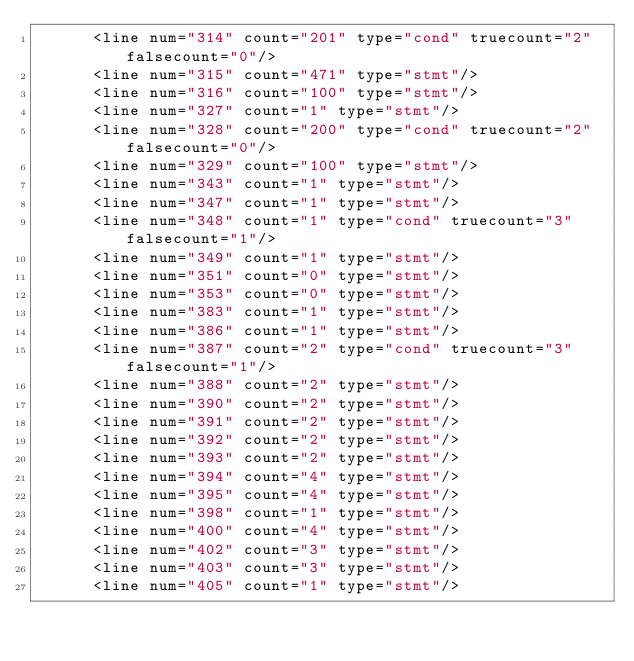<code> <loc_0><loc_0><loc_500><loc_500><_XML_>      <line num="314" count="201" type="cond" truecount="2" falsecount="0"/>
      <line num="315" count="471" type="stmt"/>
      <line num="316" count="100" type="stmt"/>
      <line num="327" count="1" type="stmt"/>
      <line num="328" count="200" type="cond" truecount="2" falsecount="0"/>
      <line num="329" count="100" type="stmt"/>
      <line num="343" count="1" type="stmt"/>
      <line num="347" count="1" type="stmt"/>
      <line num="348" count="1" type="cond" truecount="3" falsecount="1"/>
      <line num="349" count="1" type="stmt"/>
      <line num="351" count="0" type="stmt"/>
      <line num="353" count="0" type="stmt"/>
      <line num="383" count="1" type="stmt"/>
      <line num="386" count="1" type="stmt"/>
      <line num="387" count="2" type="cond" truecount="3" falsecount="1"/>
      <line num="388" count="2" type="stmt"/>
      <line num="390" count="2" type="stmt"/>
      <line num="391" count="2" type="stmt"/>
      <line num="392" count="2" type="stmt"/>
      <line num="393" count="2" type="stmt"/>
      <line num="394" count="4" type="stmt"/>
      <line num="395" count="4" type="stmt"/>
      <line num="398" count="1" type="stmt"/>
      <line num="400" count="4" type="stmt"/>
      <line num="402" count="3" type="stmt"/>
      <line num="403" count="3" type="stmt"/>
      <line num="405" count="1" type="stmt"/></code> 